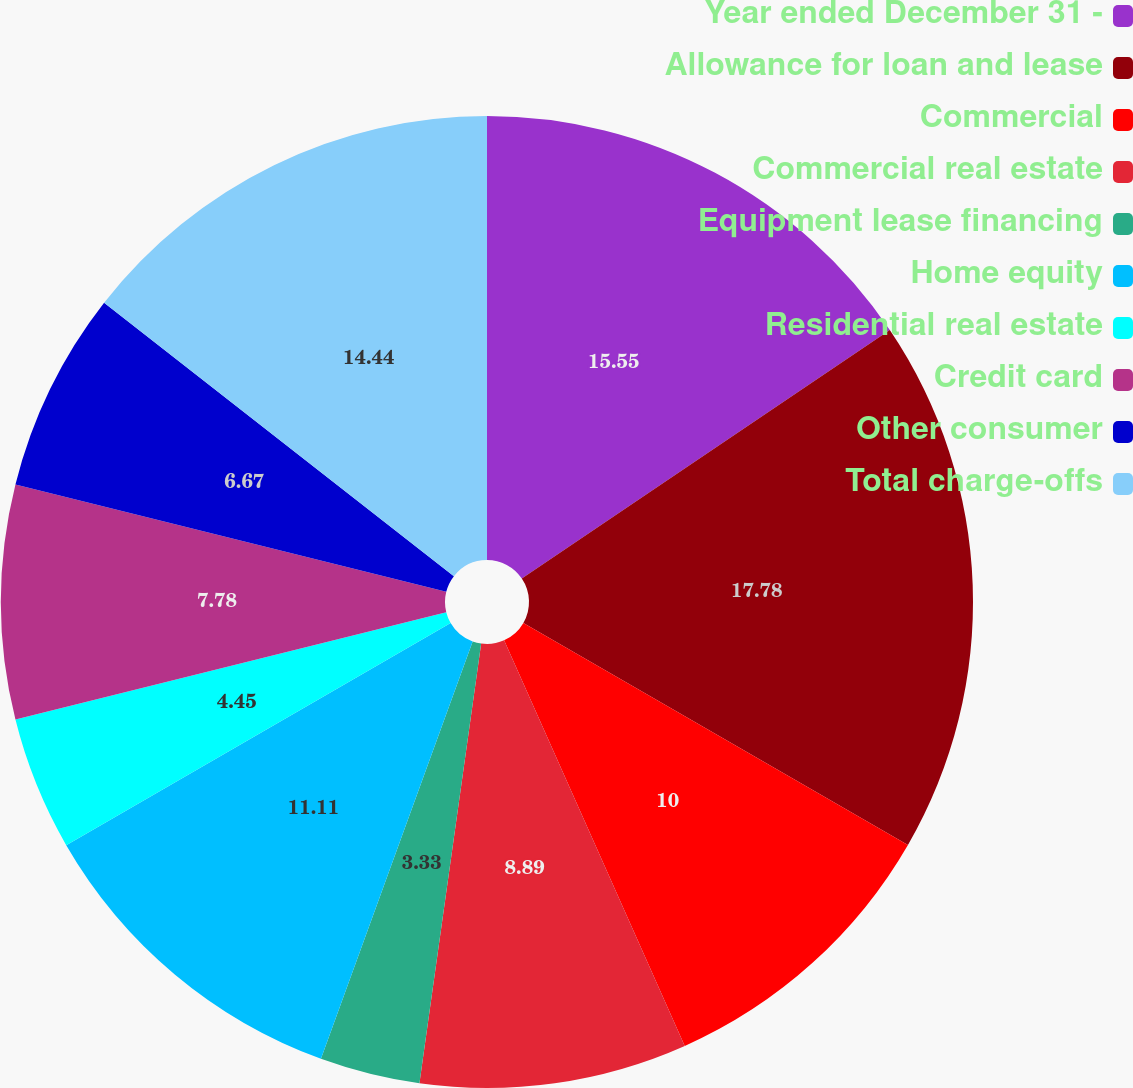<chart> <loc_0><loc_0><loc_500><loc_500><pie_chart><fcel>Year ended December 31 -<fcel>Allowance for loan and lease<fcel>Commercial<fcel>Commercial real estate<fcel>Equipment lease financing<fcel>Home equity<fcel>Residential real estate<fcel>Credit card<fcel>Other consumer<fcel>Total charge-offs<nl><fcel>15.55%<fcel>17.78%<fcel>10.0%<fcel>8.89%<fcel>3.33%<fcel>11.11%<fcel>4.45%<fcel>7.78%<fcel>6.67%<fcel>14.44%<nl></chart> 